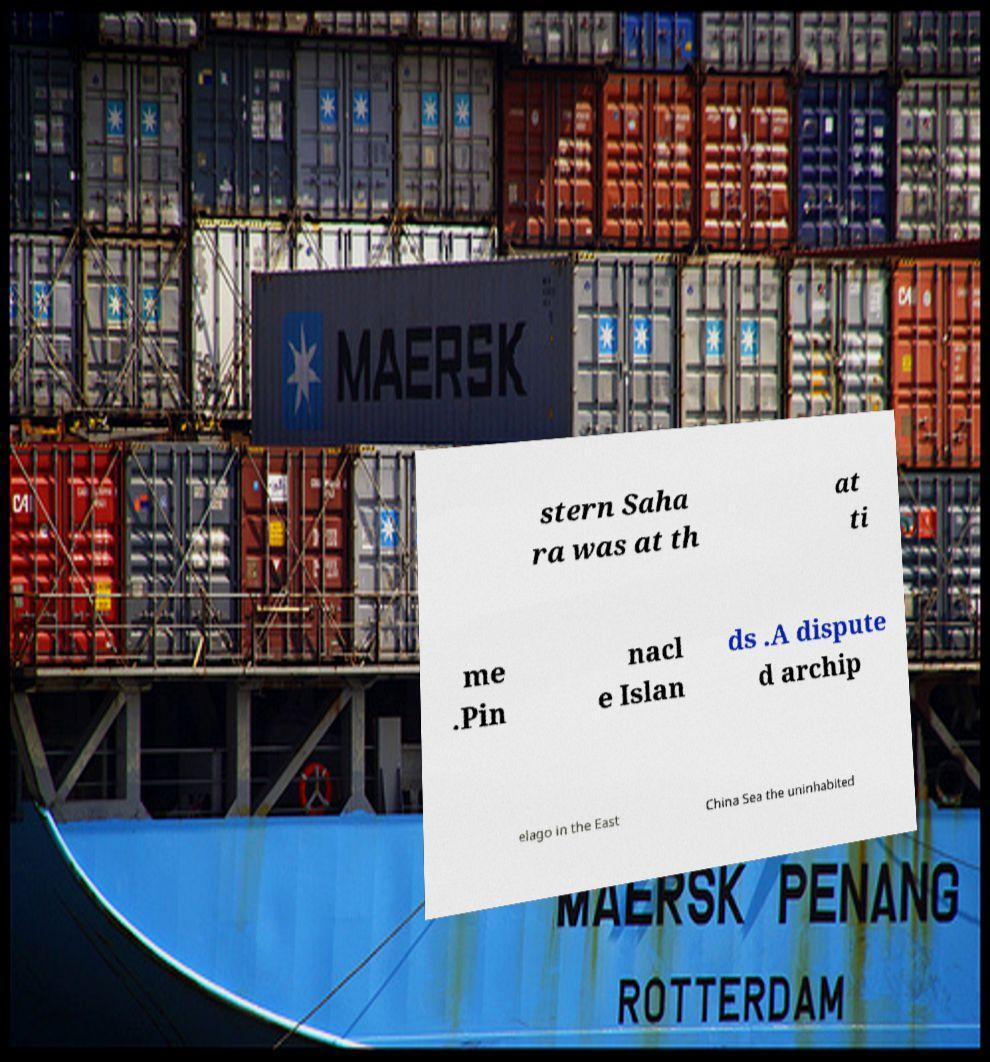Please identify and transcribe the text found in this image. stern Saha ra was at th at ti me .Pin nacl e Islan ds .A dispute d archip elago in the East China Sea the uninhabited 